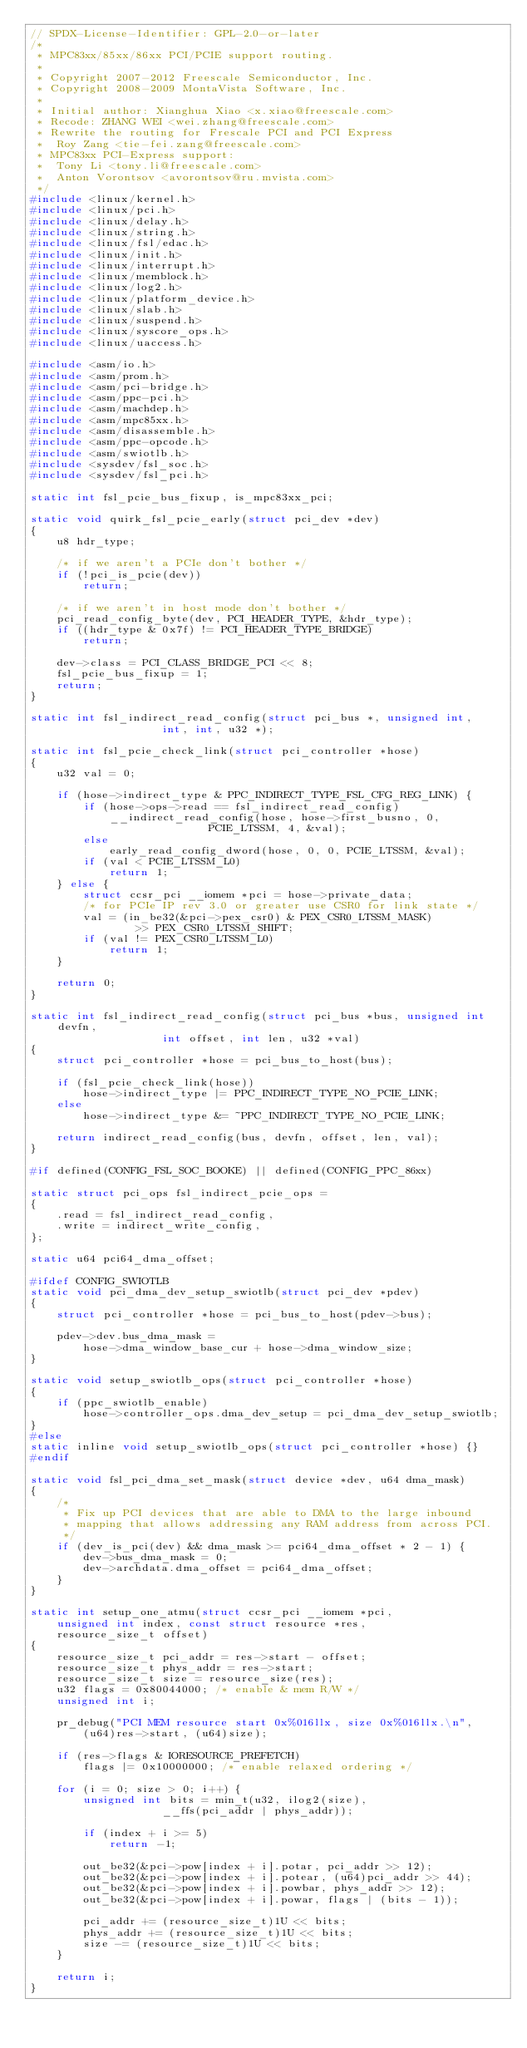<code> <loc_0><loc_0><loc_500><loc_500><_C_>// SPDX-License-Identifier: GPL-2.0-or-later
/*
 * MPC83xx/85xx/86xx PCI/PCIE support routing.
 *
 * Copyright 2007-2012 Freescale Semiconductor, Inc.
 * Copyright 2008-2009 MontaVista Software, Inc.
 *
 * Initial author: Xianghua Xiao <x.xiao@freescale.com>
 * Recode: ZHANG WEI <wei.zhang@freescale.com>
 * Rewrite the routing for Frescale PCI and PCI Express
 * 	Roy Zang <tie-fei.zang@freescale.com>
 * MPC83xx PCI-Express support:
 * 	Tony Li <tony.li@freescale.com>
 * 	Anton Vorontsov <avorontsov@ru.mvista.com>
 */
#include <linux/kernel.h>
#include <linux/pci.h>
#include <linux/delay.h>
#include <linux/string.h>
#include <linux/fsl/edac.h>
#include <linux/init.h>
#include <linux/interrupt.h>
#include <linux/memblock.h>
#include <linux/log2.h>
#include <linux/platform_device.h>
#include <linux/slab.h>
#include <linux/suspend.h>
#include <linux/syscore_ops.h>
#include <linux/uaccess.h>

#include <asm/io.h>
#include <asm/prom.h>
#include <asm/pci-bridge.h>
#include <asm/ppc-pci.h>
#include <asm/machdep.h>
#include <asm/mpc85xx.h>
#include <asm/disassemble.h>
#include <asm/ppc-opcode.h>
#include <asm/swiotlb.h>
#include <sysdev/fsl_soc.h>
#include <sysdev/fsl_pci.h>

static int fsl_pcie_bus_fixup, is_mpc83xx_pci;

static void quirk_fsl_pcie_early(struct pci_dev *dev)
{
	u8 hdr_type;

	/* if we aren't a PCIe don't bother */
	if (!pci_is_pcie(dev))
		return;

	/* if we aren't in host mode don't bother */
	pci_read_config_byte(dev, PCI_HEADER_TYPE, &hdr_type);
	if ((hdr_type & 0x7f) != PCI_HEADER_TYPE_BRIDGE)
		return;

	dev->class = PCI_CLASS_BRIDGE_PCI << 8;
	fsl_pcie_bus_fixup = 1;
	return;
}

static int fsl_indirect_read_config(struct pci_bus *, unsigned int,
				    int, int, u32 *);

static int fsl_pcie_check_link(struct pci_controller *hose)
{
	u32 val = 0;

	if (hose->indirect_type & PPC_INDIRECT_TYPE_FSL_CFG_REG_LINK) {
		if (hose->ops->read == fsl_indirect_read_config)
			__indirect_read_config(hose, hose->first_busno, 0,
					       PCIE_LTSSM, 4, &val);
		else
			early_read_config_dword(hose, 0, 0, PCIE_LTSSM, &val);
		if (val < PCIE_LTSSM_L0)
			return 1;
	} else {
		struct ccsr_pci __iomem *pci = hose->private_data;
		/* for PCIe IP rev 3.0 or greater use CSR0 for link state */
		val = (in_be32(&pci->pex_csr0) & PEX_CSR0_LTSSM_MASK)
				>> PEX_CSR0_LTSSM_SHIFT;
		if (val != PEX_CSR0_LTSSM_L0)
			return 1;
	}

	return 0;
}

static int fsl_indirect_read_config(struct pci_bus *bus, unsigned int devfn,
				    int offset, int len, u32 *val)
{
	struct pci_controller *hose = pci_bus_to_host(bus);

	if (fsl_pcie_check_link(hose))
		hose->indirect_type |= PPC_INDIRECT_TYPE_NO_PCIE_LINK;
	else
		hose->indirect_type &= ~PPC_INDIRECT_TYPE_NO_PCIE_LINK;

	return indirect_read_config(bus, devfn, offset, len, val);
}

#if defined(CONFIG_FSL_SOC_BOOKE) || defined(CONFIG_PPC_86xx)

static struct pci_ops fsl_indirect_pcie_ops =
{
	.read = fsl_indirect_read_config,
	.write = indirect_write_config,
};

static u64 pci64_dma_offset;

#ifdef CONFIG_SWIOTLB
static void pci_dma_dev_setup_swiotlb(struct pci_dev *pdev)
{
	struct pci_controller *hose = pci_bus_to_host(pdev->bus);

	pdev->dev.bus_dma_mask =
		hose->dma_window_base_cur + hose->dma_window_size;
}

static void setup_swiotlb_ops(struct pci_controller *hose)
{
	if (ppc_swiotlb_enable)
		hose->controller_ops.dma_dev_setup = pci_dma_dev_setup_swiotlb;
}
#else
static inline void setup_swiotlb_ops(struct pci_controller *hose) {}
#endif

static void fsl_pci_dma_set_mask(struct device *dev, u64 dma_mask)
{
	/*
	 * Fix up PCI devices that are able to DMA to the large inbound
	 * mapping that allows addressing any RAM address from across PCI.
	 */
	if (dev_is_pci(dev) && dma_mask >= pci64_dma_offset * 2 - 1) {
		dev->bus_dma_mask = 0;
		dev->archdata.dma_offset = pci64_dma_offset;
	}
}

static int setup_one_atmu(struct ccsr_pci __iomem *pci,
	unsigned int index, const struct resource *res,
	resource_size_t offset)
{
	resource_size_t pci_addr = res->start - offset;
	resource_size_t phys_addr = res->start;
	resource_size_t size = resource_size(res);
	u32 flags = 0x80044000; /* enable & mem R/W */
	unsigned int i;

	pr_debug("PCI MEM resource start 0x%016llx, size 0x%016llx.\n",
		(u64)res->start, (u64)size);

	if (res->flags & IORESOURCE_PREFETCH)
		flags |= 0x10000000; /* enable relaxed ordering */

	for (i = 0; size > 0; i++) {
		unsigned int bits = min_t(u32, ilog2(size),
					__ffs(pci_addr | phys_addr));

		if (index + i >= 5)
			return -1;

		out_be32(&pci->pow[index + i].potar, pci_addr >> 12);
		out_be32(&pci->pow[index + i].potear, (u64)pci_addr >> 44);
		out_be32(&pci->pow[index + i].powbar, phys_addr >> 12);
		out_be32(&pci->pow[index + i].powar, flags | (bits - 1));

		pci_addr += (resource_size_t)1U << bits;
		phys_addr += (resource_size_t)1U << bits;
		size -= (resource_size_t)1U << bits;
	}

	return i;
}
</code> 